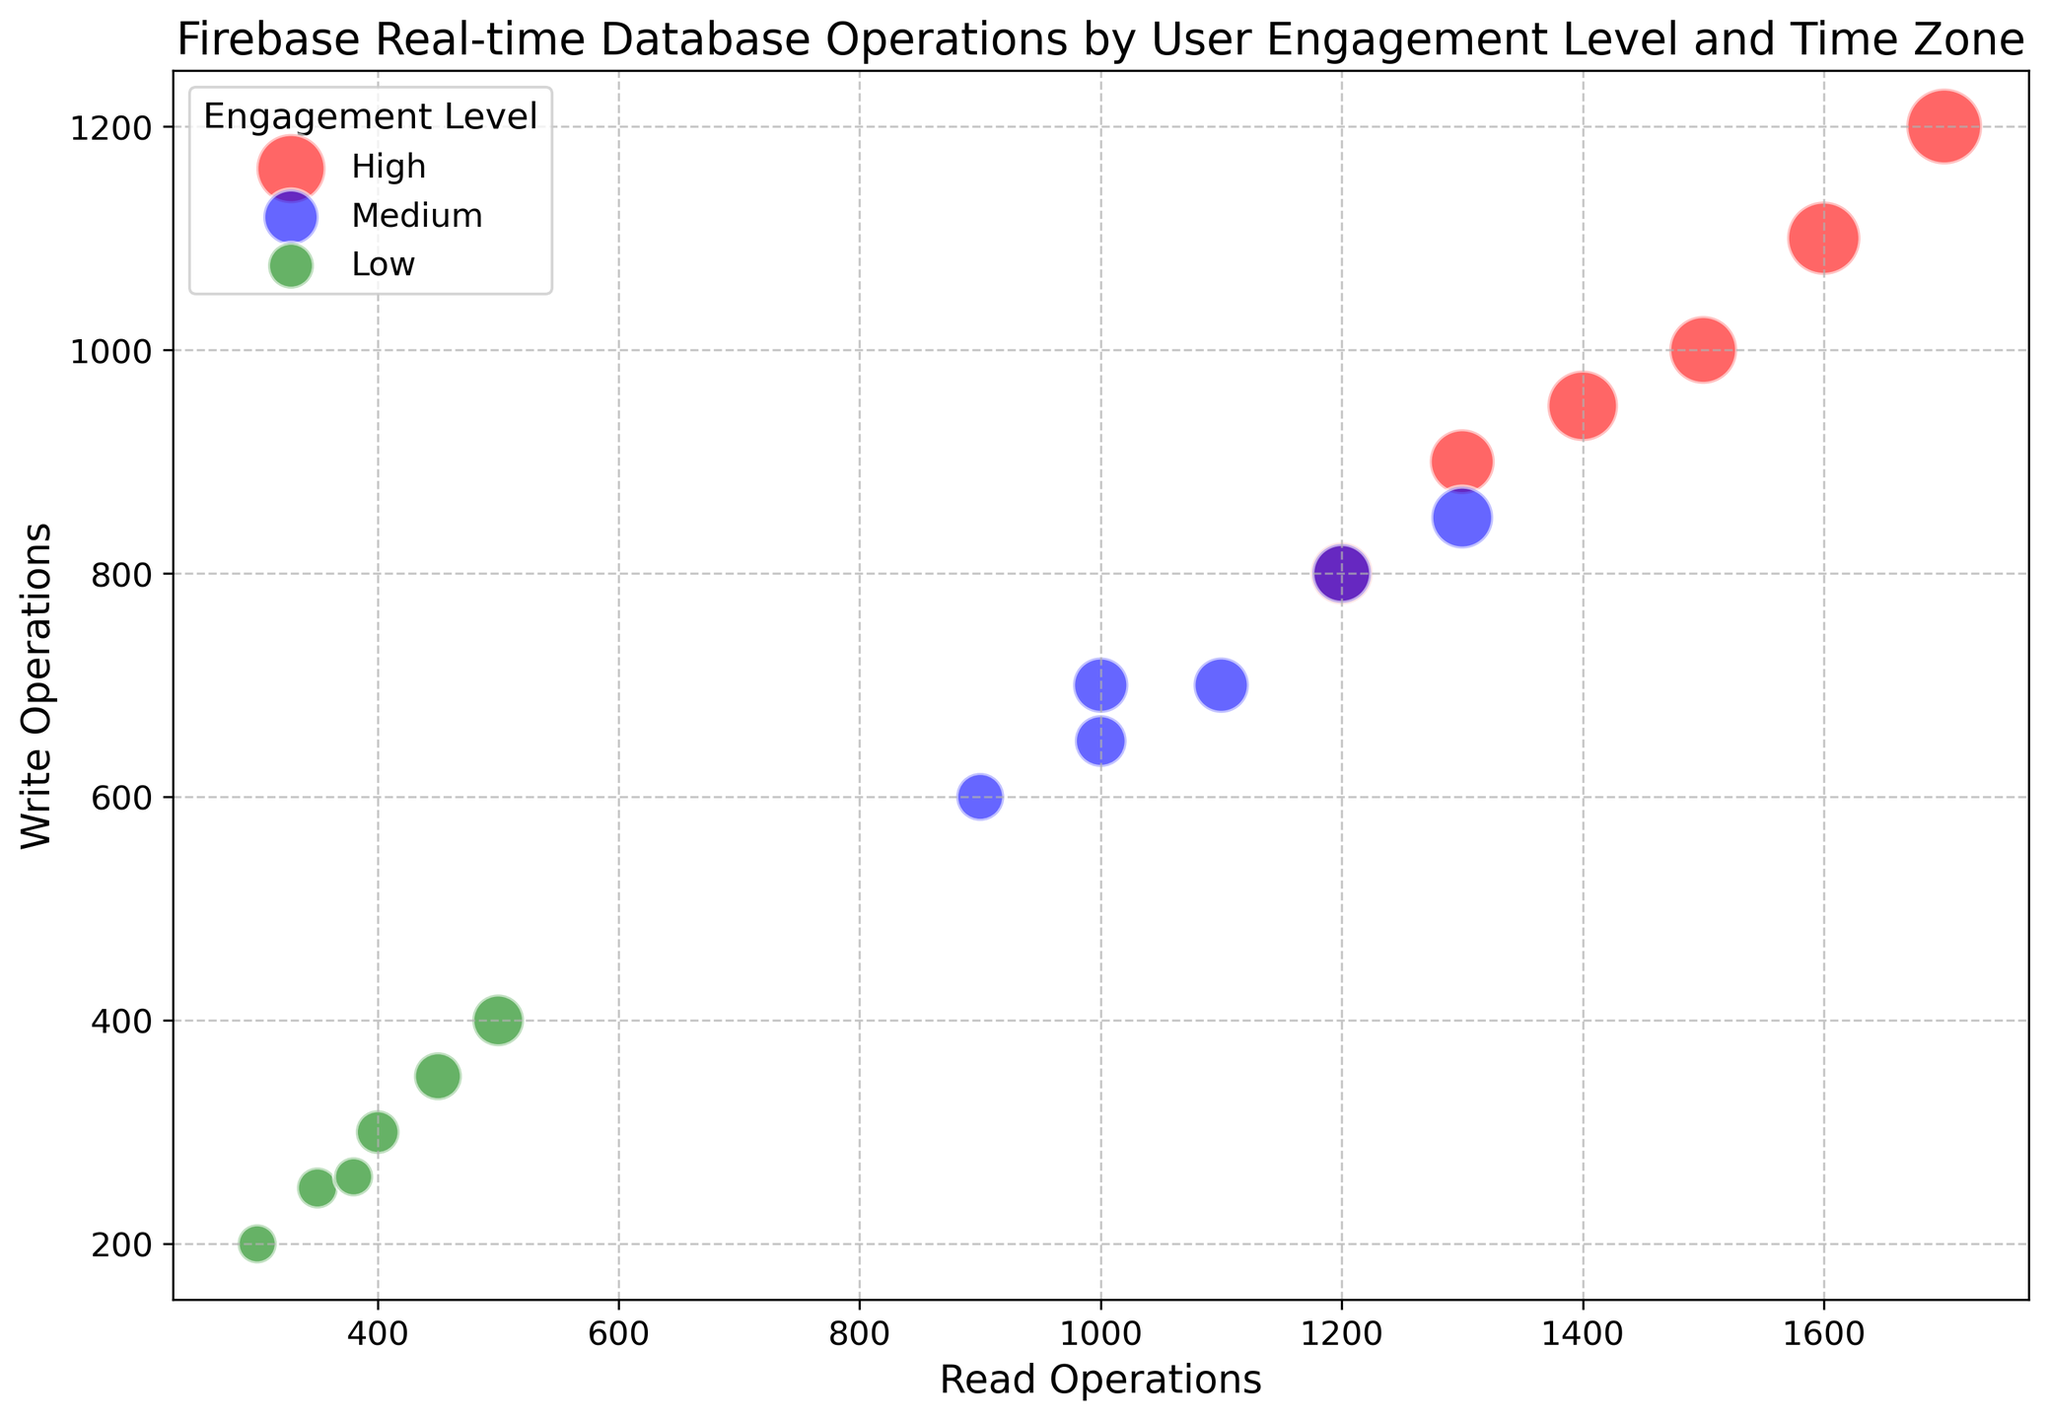Which time zone and engagement level have the highest number of read operations? First, look for the highest bubble along the x-axis (read operations). Then identify the corresponding time zone and engagement level.
Answer: JST, High Which engagement level has the smallest bubbles and what does this represent? The smallest bubbles are green, representing the low engagement level across all time zones. The bubble size indicates the number of users, so low engagement has fewer users.
Answer: Low engagement, fewer users What’s the sum of write operations for high engagement levels across all time zones? Sum the y-values (write operations) for all high engagement bubbles: 800 (PST) + 1000 (EST) + 900 (CET) + 1100 (IST) + 1200 (JST) + 950 (GMT).
Answer: 5950 Which time zone has the most balanced read and write operations (read and write operations values close to each other) for medium engagement? Compare the proximity of x (read) and y (write) values for medium engagement across time zones. PST has 900:600, EST has 1100:700, CET has 1000:650, IST has 1200:800, JST has 1300:850, and GMT has 1000:700. PST (900, 600) has the least difference.
Answer: PST For high engagement, which time zone has the highest user count? Look for the largest red bubble (high engagement) and identify its corresponding time zone.
Answer: JST What’s the average number of read operations for the low engagement level across all time zones? Sum the read operations for all low engagement bubbles and divide by the number of time zones: (300+400+350+450+500+380)/6.
Answer: 396.67 Compare the ratio of read to write operations for the high engagement level in PST and EST. Which one reads more relative to writes? Compute the ratio of read to write for both: PST (1200/800 = 1.5) and EST (1500/1000 = 1.5). Both ratios are equal.
Answer: Both are equal How many more write operations are there in IST compared to GMT for the high engagement level? Subtract the y-values (write operations) for high engagement in GMT from IST: 1100 (IST) - 950 (GMT).
Answer: 150 Which time zone has the highest total number of operations (read + write) for medium engagement? Sum the read and write operations for all medium engagement levels: PST (900+600 = 1500), EST (1100+700 = 1800), CET (1000+650 = 1650), IST (1200+800 = 2000), JST (1300+850 = 2150), GMT (1000+700 = 1700). JST has the highest total (2150).
Answer: JST Which engagement level has the largest variation in bubble sizes across time zones? Observe the varying sizes of the bubbles of each engagement level. High and Medium engagement levels have more substantial variation compared to Low.
Answer: High and Medium 